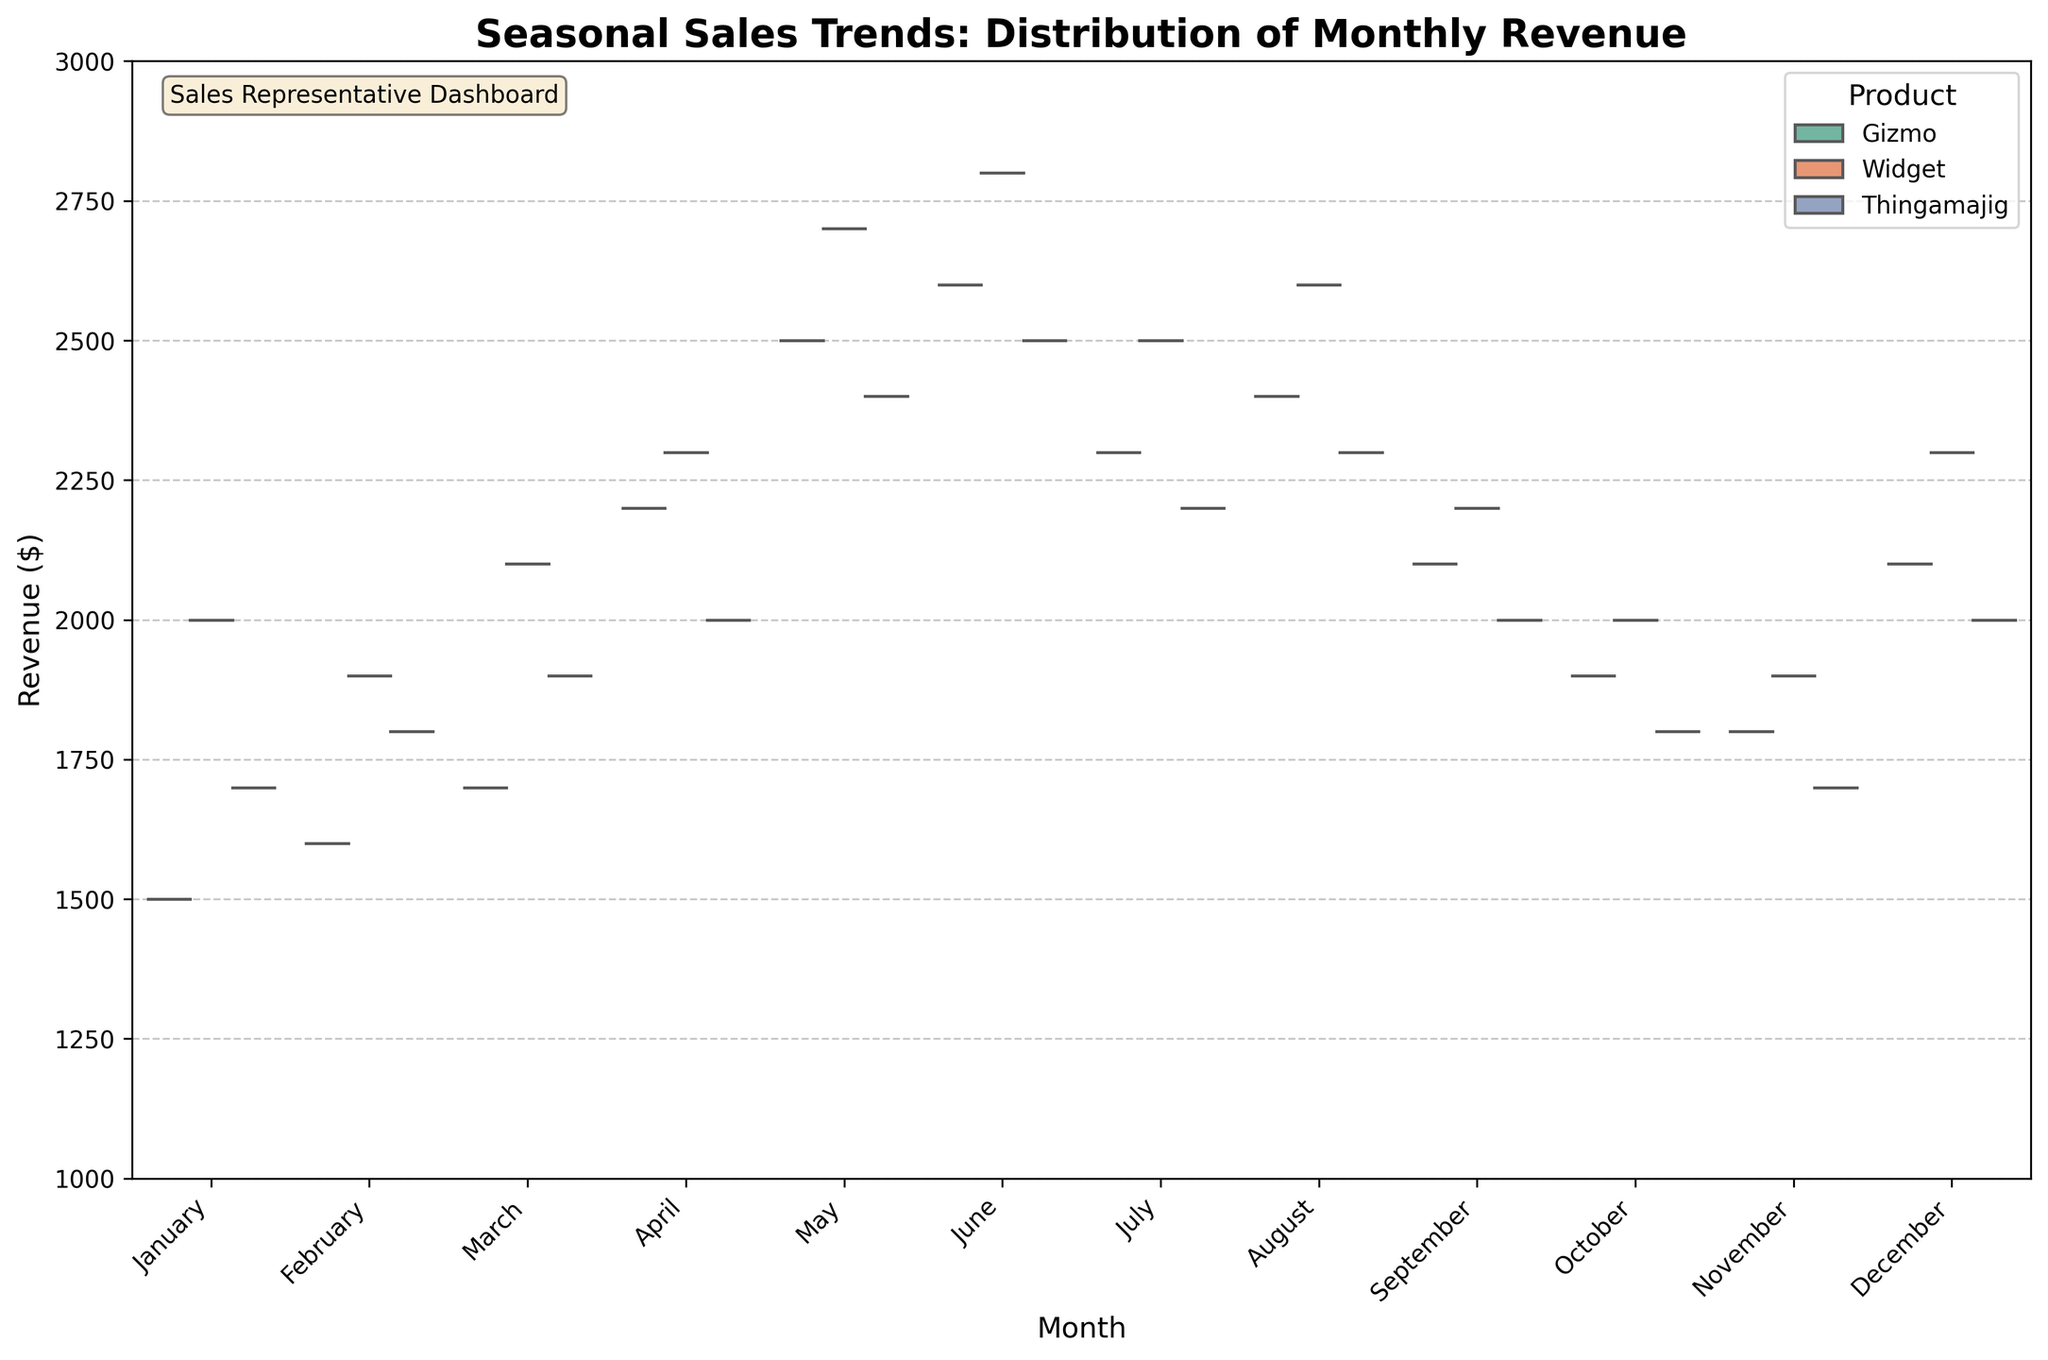What is the title of the violin chart? The title of the figure is at the top and provides an overview of what the plot represents. In this case, it reads "Seasonal Sales Trends: Distribution of Monthly Revenue".
Answer: Seasonal Sales Trends: Distribution of Monthly Revenue What are the products compared in this violin chart? The legend on the figure indicates the different categories being compared, which are "Gizmo", "Widget", and "Thingamajig".
Answer: Gizmo, Widget, Thingamajig Which month shows the highest revenue distribution for Widgets? By examining the distribution for Widgets across all months, May and June have the highest revenue distribution, with June showing a slightly higher upper range in the violin plot.
Answer: June How does the median revenue for Gizmos in April compare to the median revenue in November? The darker line in each distribution represents the median. In April, the median revenue for Gizmos is higher than in November.
Answer: Higher Which month has the widest revenue distribution for Thingamajigs? The width of the violin plot indicates the distribution spread. April and December have the widest distributions for Thingamajigs.
Answer: April Between which two months did Widgets see the most significant increase in median revenue? By comparing the median lines, there is a noticeable increase between March and April. The line jumps significantly from March to April.
Answer: March to April In what months do all three products show a declining trend in median revenue? Observing the lines for median revenue across months for all three products, the declining trend is visible from June to November.
Answer: June to November Which product has the highest median revenue in December? The darker central line on the distribution for December indicates that Widgets have the highest median revenue.
Answer: Widget Is there a month where Gizmos' revenue distribution is entirely higher than Thingamajigs'? Yes, in May, the entire distribution of Gizmos is above that of Thingamajigs.
Answer: May How does the sales distribution of Gizmos change from January to July? Following the shape and position of the violin plot for Gizmos from January to July, we see an increasing trend peaking in June and then declining in July.
Answer: Increases till June then decreases 